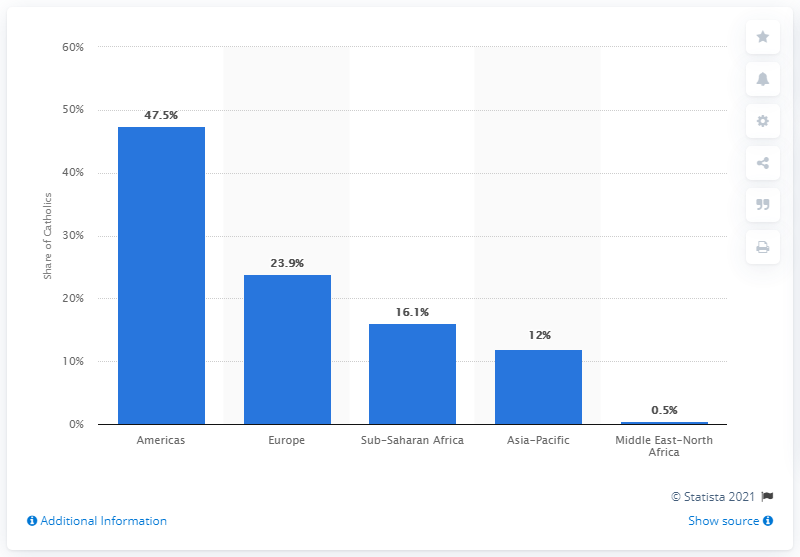Draw attention to some important aspects in this diagram. In 2010, 23.9% of Catholics lived in Europe. 